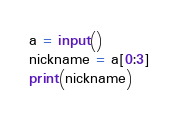Convert code to text. <code><loc_0><loc_0><loc_500><loc_500><_Python_>a = input()
nickname = a[0:3]
print(nickname)</code> 